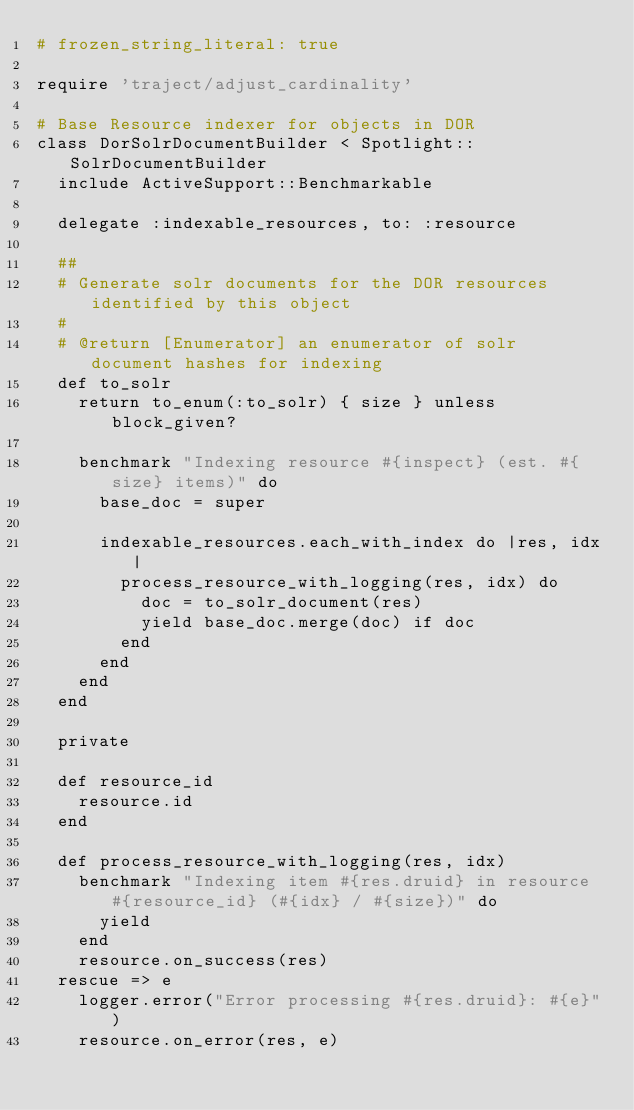<code> <loc_0><loc_0><loc_500><loc_500><_Ruby_># frozen_string_literal: true

require 'traject/adjust_cardinality'

# Base Resource indexer for objects in DOR
class DorSolrDocumentBuilder < Spotlight::SolrDocumentBuilder
  include ActiveSupport::Benchmarkable

  delegate :indexable_resources, to: :resource

  ##
  # Generate solr documents for the DOR resources identified by this object
  #
  # @return [Enumerator] an enumerator of solr document hashes for indexing
  def to_solr
    return to_enum(:to_solr) { size } unless block_given?

    benchmark "Indexing resource #{inspect} (est. #{size} items)" do
      base_doc = super

      indexable_resources.each_with_index do |res, idx|
        process_resource_with_logging(res, idx) do
          doc = to_solr_document(res)
          yield base_doc.merge(doc) if doc
        end
      end
    end
  end

  private

  def resource_id
    resource.id
  end

  def process_resource_with_logging(res, idx)
    benchmark "Indexing item #{res.druid} in resource #{resource_id} (#{idx} / #{size})" do
      yield
    end
    resource.on_success(res)
  rescue => e
    logger.error("Error processing #{res.druid}: #{e}")
    resource.on_error(res, e)</code> 